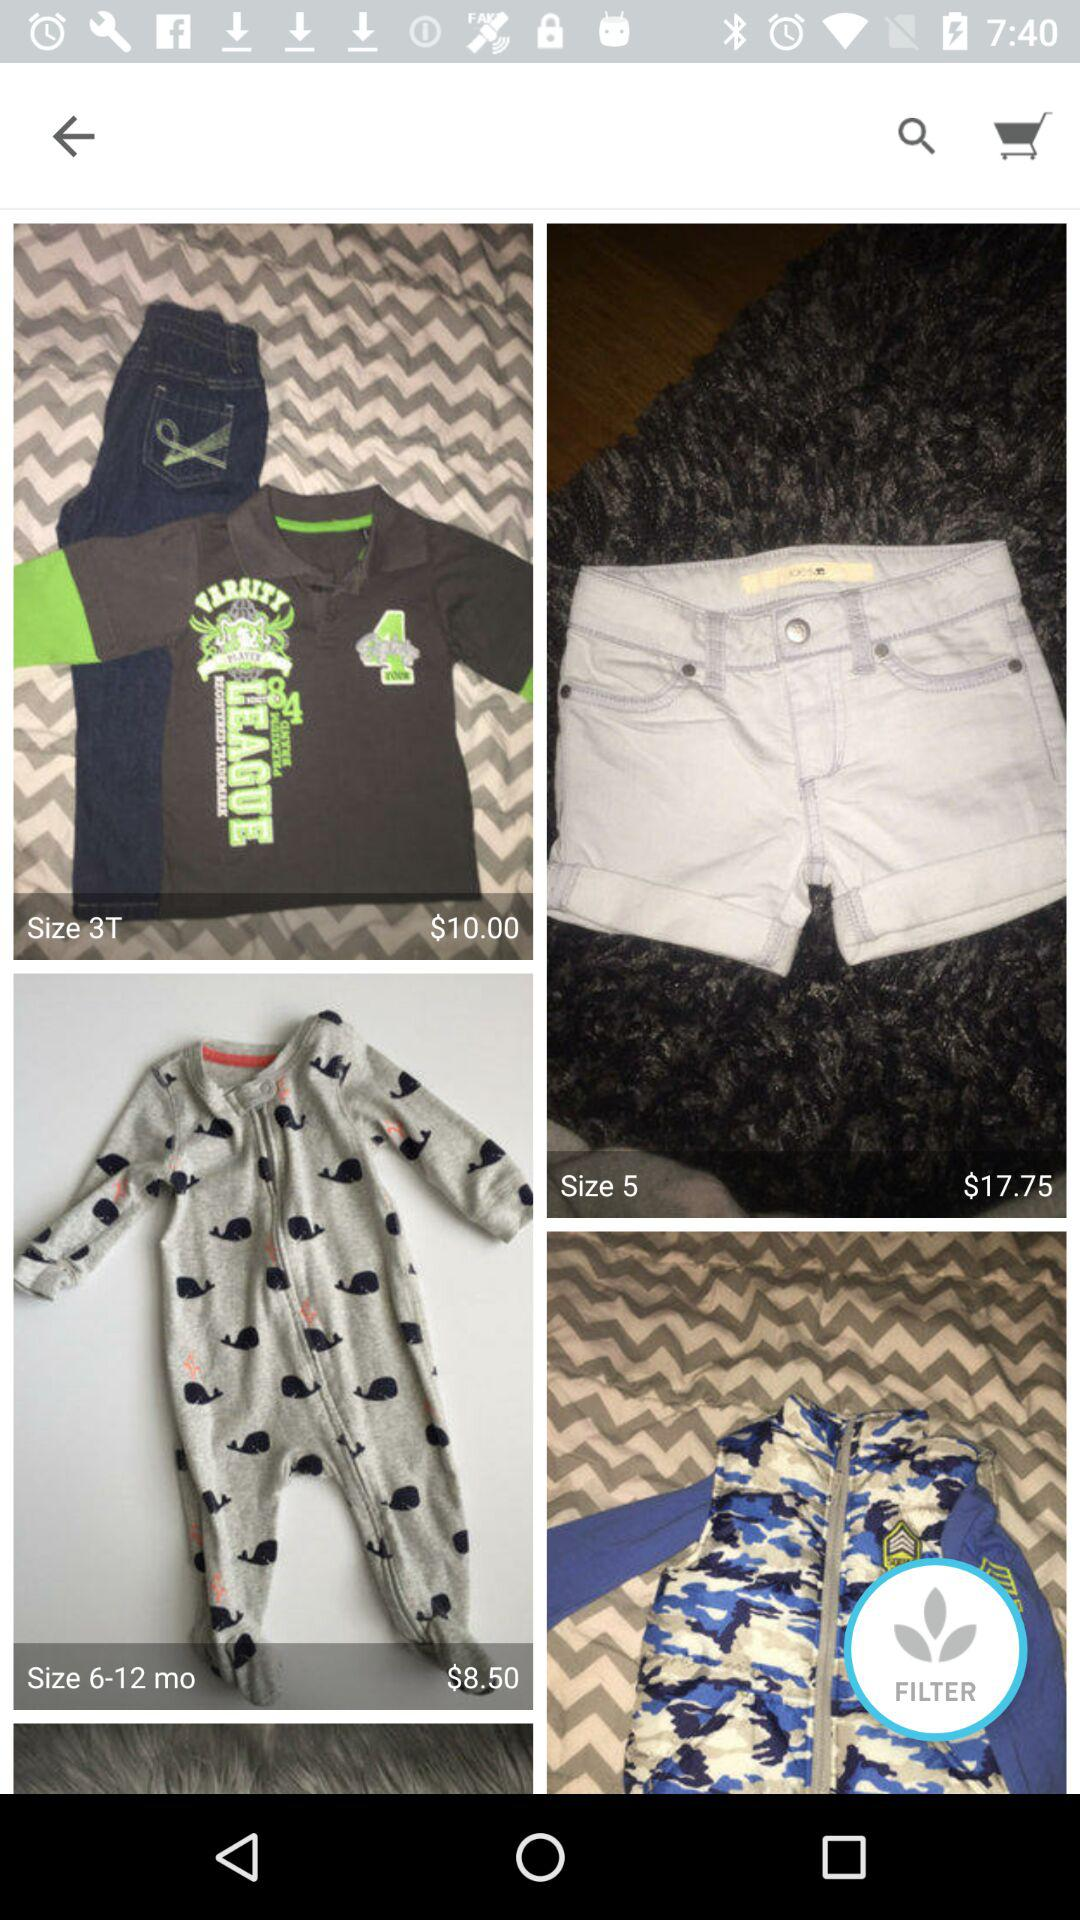What is the price of clothes?
When the provided information is insufficient, respond with <no answer>. <no answer> 